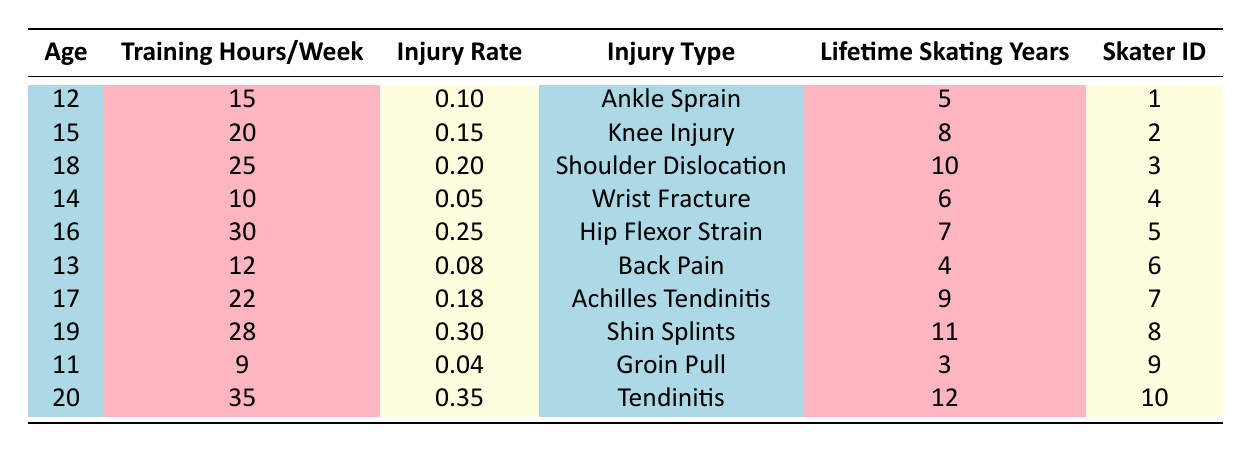What is the injury rate for the skater who trains 30 hours per week? According to the table, the skater who trains 30 hours per week is Skater ID 5. The injury rate listed for this skater is 0.25.
Answer: 0.25 What types of injuries are reported for skaters aged 18 and above? The table indicates that the skaters aged 18 and above are Skater ID 3 (Shoulder Dislocation), Skater ID 5 (Hip Flexor Strain), Skater ID 7 (Achilles Tendinitis), Skater ID 8 (Shin Splints), and Skater ID 10 (Tendinitis). The types of injuries are Shoulder Dislocation, Hip Flexor Strain, Achilles Tendinitis, Shin Splints, and Tendinitis.
Answer: Shoulder Dislocation, Hip Flexor Strain, Achilles Tendinitis, Shin Splints, Tendinitis Which skater has the highest injury rate and what is that rate? The table shows that Skater ID 10 has the highest injury rate at 0.35.
Answer: 0.35 What is the average training hours per week for skaters with an injury rate greater than 0.15? We consider Skater ID 2 (20 hours), Skater ID 3 (25 hours), Skater ID 5 (30 hours), Skater ID 7 (22 hours), and Skater ID 8 (28 hours). The total is 20 + 25 + 30 + 22 + 28 = 125 hours. There are 5 skaters, so the average is 125 / 5 = 25 hours.
Answer: 25 hours Are skaters under the age of 15 showing an injury rate greater than 0.10? The skaters under the age of 15 are Skater ID 1 (0.10), Skater ID 4 (0.05), and Skater ID 9 (0.04). None have an injury rate greater than 0.10.
Answer: No Which injury type has the lowest reported injury rate? By checking the table, Wrist Fracture (0.05) and Groin Pull (0.04) are the lowest rates, but Groin Pull holds the lowest value.
Answer: Groin Pull What is the combined injury rate of skaters aged 15 to 19? Skaters aged 15 to 19 include Skater ID 2 (0.15), Skater ID 3 (0.20), Skater ID 5 (0.25), Skater ID 7 (0.18), and Skater ID 8 (0.30). The total is 0.15 + 0.20 + 0.25 + 0.18 + 0.30 = 1.18.
Answer: 1.18 How many skaters have an injury rate less than 0.10? Skater ID 4 has 0.05 and Skater ID 9 has 0.04. Thus, there are 2 skaters with an injury rate less than 0.10.
Answer: 2 